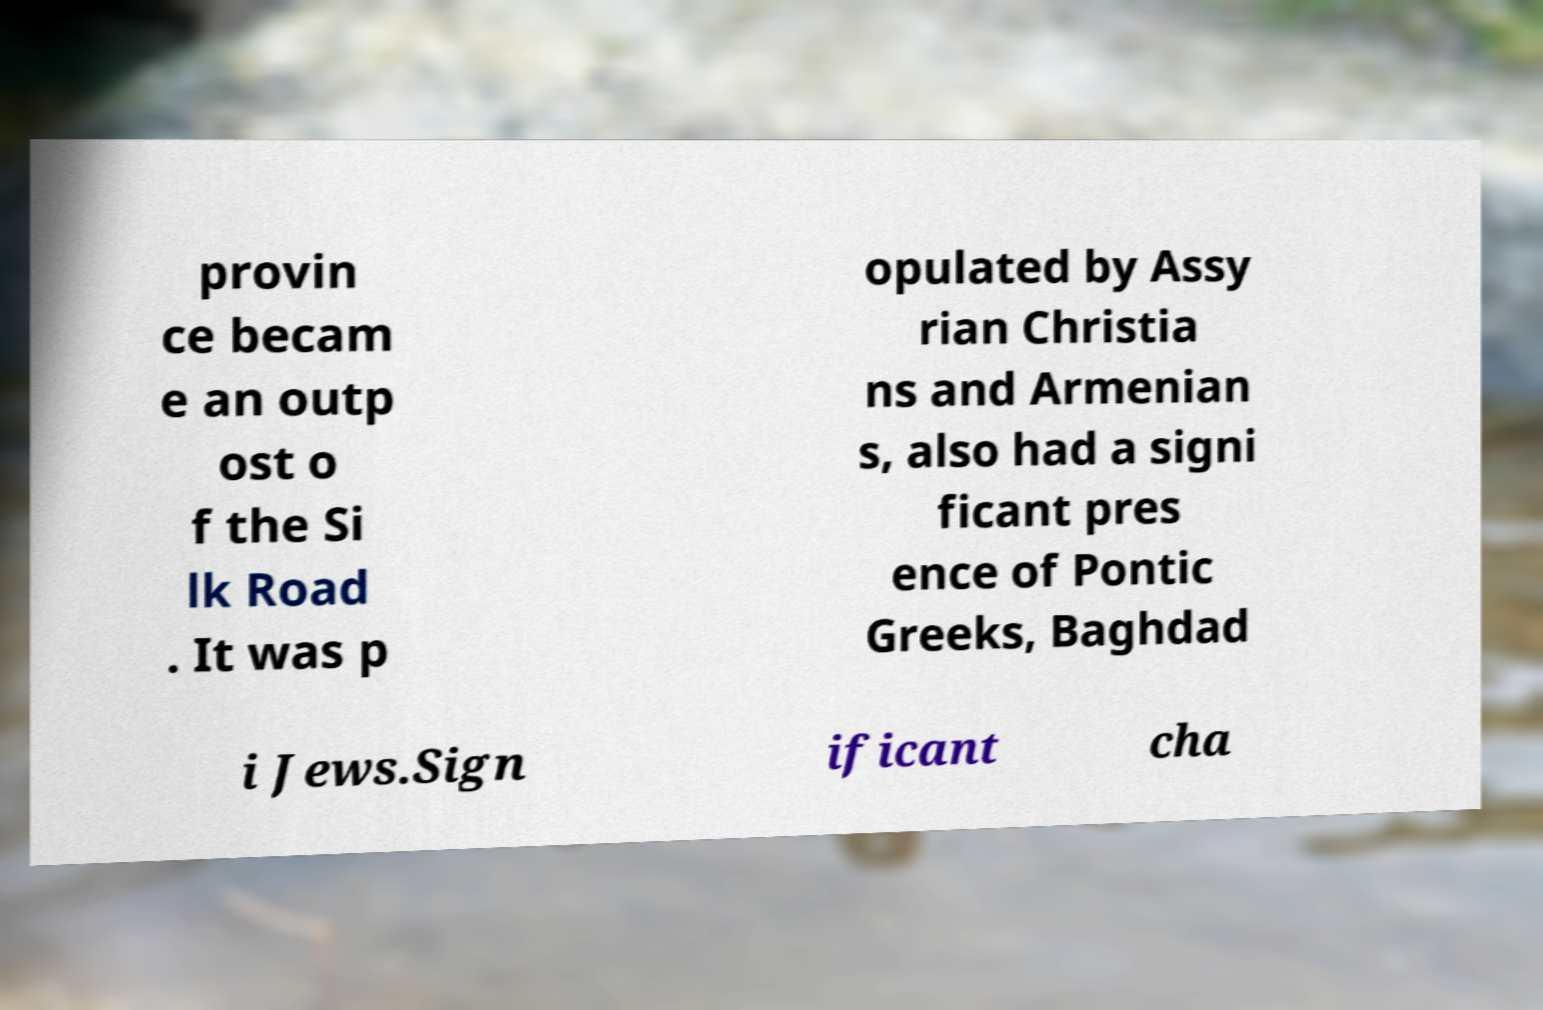Can you accurately transcribe the text from the provided image for me? provin ce becam e an outp ost o f the Si lk Road . It was p opulated by Assy rian Christia ns and Armenian s, also had a signi ficant pres ence of Pontic Greeks, Baghdad i Jews.Sign ificant cha 